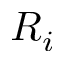<formula> <loc_0><loc_0><loc_500><loc_500>R _ { i }</formula> 